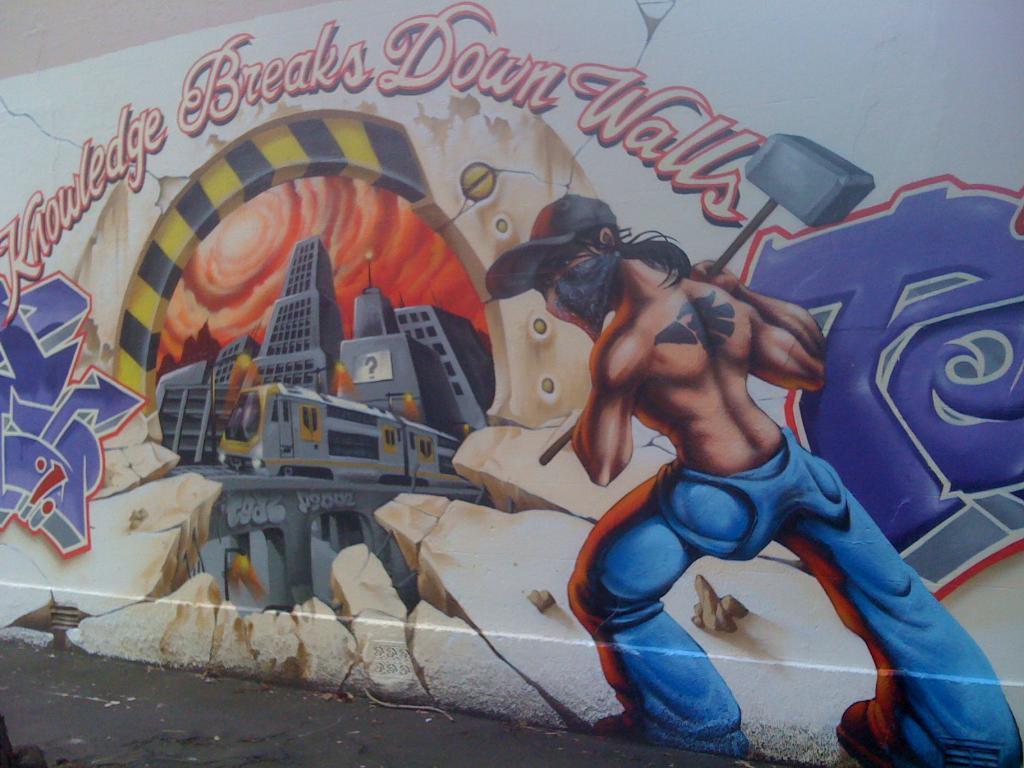In one or two sentences, can you explain what this image depicts? In the picture I can see painting of a person who is holding a hammer, buildings, the sky and something written on the wall. 